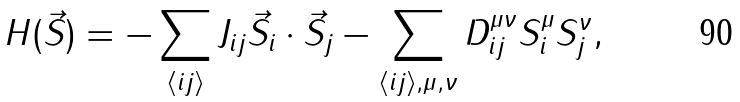Convert formula to latex. <formula><loc_0><loc_0><loc_500><loc_500>H ( \vec { S } ) = - \sum _ { \langle i j \rangle } J _ { i j } \vec { S } _ { i } \cdot \vec { S } _ { j } - \sum _ { \langle i j \rangle , \mu , \nu } D _ { i j } ^ { \mu \nu } S _ { i } ^ { \mu } S _ { j } ^ { \nu } ,</formula> 